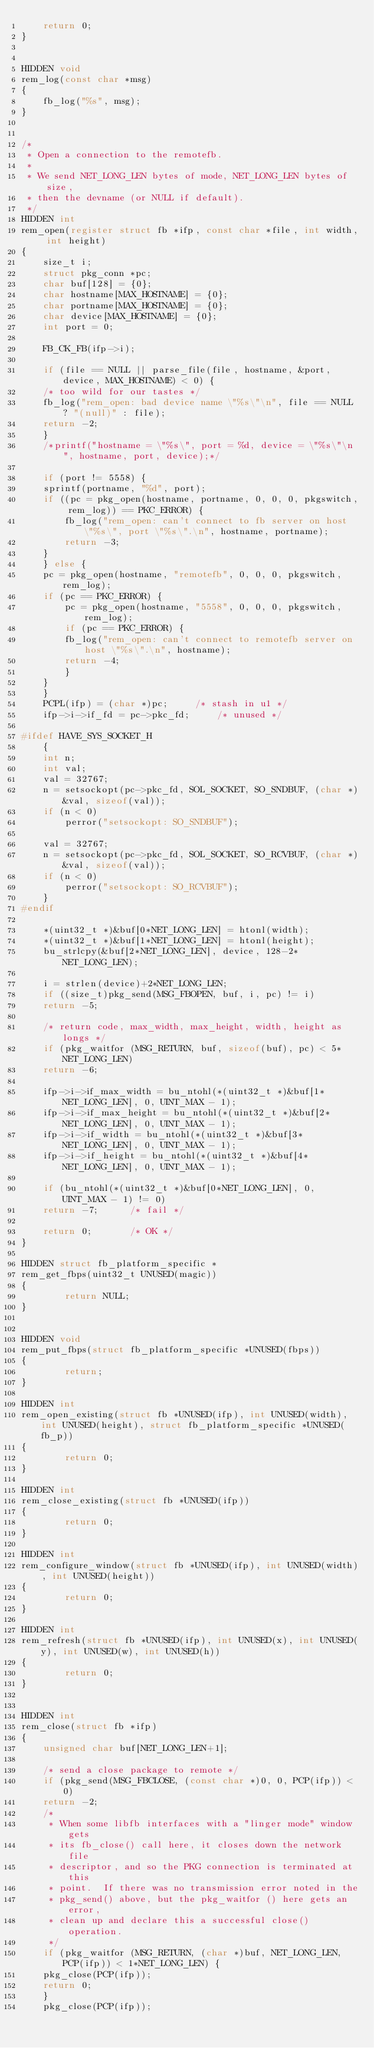Convert code to text. <code><loc_0><loc_0><loc_500><loc_500><_C_>    return 0;
}


HIDDEN void
rem_log(const char *msg)
{
    fb_log("%s", msg);
}


/*
 * Open a connection to the remotefb.
 *
 * We send NET_LONG_LEN bytes of mode, NET_LONG_LEN bytes of size,
 * then the devname (or NULL if default).
 */
HIDDEN int
rem_open(register struct fb *ifp, const char *file, int width, int height)
{
    size_t i;
    struct pkg_conn *pc;
    char buf[128] = {0};
    char hostname[MAX_HOSTNAME] = {0};
    char portname[MAX_HOSTNAME] = {0};
    char device[MAX_HOSTNAME] = {0};
    int port = 0;

    FB_CK_FB(ifp->i);

    if (file == NULL || parse_file(file, hostname, &port, device, MAX_HOSTNAME) < 0) {
	/* too wild for our tastes */
	fb_log("rem_open: bad device name \"%s\"\n", file == NULL ? "(null)" : file);
	return -2;
    }
    /*printf("hostname = \"%s\", port = %d, device = \"%s\"\n", hostname, port, device);*/

    if (port != 5558) {
	sprintf(portname, "%d", port);
	if ((pc = pkg_open(hostname, portname, 0, 0, 0, pkgswitch, rem_log)) == PKC_ERROR) {
	    fb_log("rem_open: can't connect to fb server on host \"%s\", port \"%s\".\n", hostname, portname);
	    return -3;
	}
    } else {
	pc = pkg_open(hostname, "remotefb", 0, 0, 0, pkgswitch, rem_log);
	if (pc == PKC_ERROR) {
	    pc = pkg_open(hostname, "5558", 0, 0, 0, pkgswitch, rem_log);
	    if (pc == PKC_ERROR) {
		fb_log("rem_open: can't connect to remotefb server on host \"%s\".\n", hostname);
		return -4;
	    }
	}
    }
    PCPL(ifp) = (char *)pc;		/* stash in u1 */
    ifp->i->if_fd = pc->pkc_fd;		/* unused */

#ifdef HAVE_SYS_SOCKET_H
    {
	int n;
	int val;
	val = 32767;
	n = setsockopt(pc->pkc_fd, SOL_SOCKET, SO_SNDBUF, (char *)&val, sizeof(val));
	if (n < 0)
	    perror("setsockopt: SO_SNDBUF");

	val = 32767;
	n = setsockopt(pc->pkc_fd, SOL_SOCKET, SO_RCVBUF, (char *)&val, sizeof(val));
	if (n < 0)
	    perror("setsockopt: SO_RCVBUF");
    }
#endif

    *(uint32_t *)&buf[0*NET_LONG_LEN] = htonl(width);
    *(uint32_t *)&buf[1*NET_LONG_LEN] = htonl(height);
    bu_strlcpy(&buf[2*NET_LONG_LEN], device, 128-2*NET_LONG_LEN);

    i = strlen(device)+2*NET_LONG_LEN;
    if ((size_t)pkg_send(MSG_FBOPEN, buf, i, pc) != i)
	return -5;

    /* return code, max_width, max_height, width, height as longs */
    if (pkg_waitfor (MSG_RETURN, buf, sizeof(buf), pc) < 5*NET_LONG_LEN)
	return -6;

    ifp->i->if_max_width = bu_ntohl(*(uint32_t *)&buf[1*NET_LONG_LEN], 0, UINT_MAX - 1);
    ifp->i->if_max_height = bu_ntohl(*(uint32_t *)&buf[2*NET_LONG_LEN], 0, UINT_MAX - 1);
    ifp->i->if_width = bu_ntohl(*(uint32_t *)&buf[3*NET_LONG_LEN], 0, UINT_MAX - 1);
    ifp->i->if_height = bu_ntohl(*(uint32_t *)&buf[4*NET_LONG_LEN], 0, UINT_MAX - 1);

    if (bu_ntohl(*(uint32_t *)&buf[0*NET_LONG_LEN], 0, UINT_MAX - 1) != 0)
	return -7;		/* fail */

    return 0;		/* OK */
}

HIDDEN struct fb_platform_specific *
rem_get_fbps(uint32_t UNUSED(magic))
{
        return NULL;
}


HIDDEN void
rem_put_fbps(struct fb_platform_specific *UNUSED(fbps))
{
        return;
}

HIDDEN int
rem_open_existing(struct fb *UNUSED(ifp), int UNUSED(width), int UNUSED(height), struct fb_platform_specific *UNUSED(fb_p))
{
        return 0;
}

HIDDEN int
rem_close_existing(struct fb *UNUSED(ifp))
{
        return 0;
}

HIDDEN int
rem_configure_window(struct fb *UNUSED(ifp), int UNUSED(width), int UNUSED(height))
{
        return 0;
}

HIDDEN int
rem_refresh(struct fb *UNUSED(ifp), int UNUSED(x), int UNUSED(y), int UNUSED(w), int UNUSED(h))
{
        return 0;
}


HIDDEN int
rem_close(struct fb *ifp)
{
    unsigned char buf[NET_LONG_LEN+1];

    /* send a close package to remote */
    if (pkg_send(MSG_FBCLOSE, (const char *)0, 0, PCP(ifp)) < 0)
	return -2;
    /*
     * When some libfb interfaces with a "linger mode" window gets
     * its fb_close() call here, it closes down the network file
     * descriptor, and so the PKG connection is terminated at this
     * point.  If there was no transmission error noted in the
     * pkg_send() above, but the pkg_waitfor () here gets an error,
     * clean up and declare this a successful close() operation.
     */
    if (pkg_waitfor (MSG_RETURN, (char *)buf, NET_LONG_LEN, PCP(ifp)) < 1*NET_LONG_LEN) {
	pkg_close(PCP(ifp));
	return 0;
    }
    pkg_close(PCP(ifp));</code> 